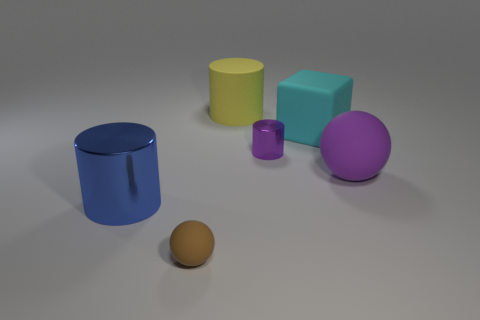What size is the metal object that is in front of the rubber ball that is on the right side of the cyan thing?
Your answer should be compact. Large. What is the size of the cylinder that is the same material as the blue object?
Your response must be concise. Small. What shape is the large object that is right of the tiny purple shiny cylinder and in front of the matte block?
Give a very brief answer. Sphere. Are there the same number of purple cylinders that are to the right of the tiny purple metal cylinder and small metallic cylinders?
Your response must be concise. No. What number of things are either tiny cylinders or things that are behind the brown matte thing?
Your answer should be very brief. 5. Is there a purple shiny object that has the same shape as the blue metallic object?
Your answer should be very brief. Yes. Is the number of large objects on the left side of the purple metallic object the same as the number of large purple objects that are right of the brown thing?
Your answer should be very brief. No. What number of cyan objects are metal things or big rubber blocks?
Provide a short and direct response. 1. How many purple shiny things are the same size as the brown thing?
Your answer should be compact. 1. What is the color of the big object that is on the right side of the tiny matte sphere and in front of the purple cylinder?
Your response must be concise. Purple. 